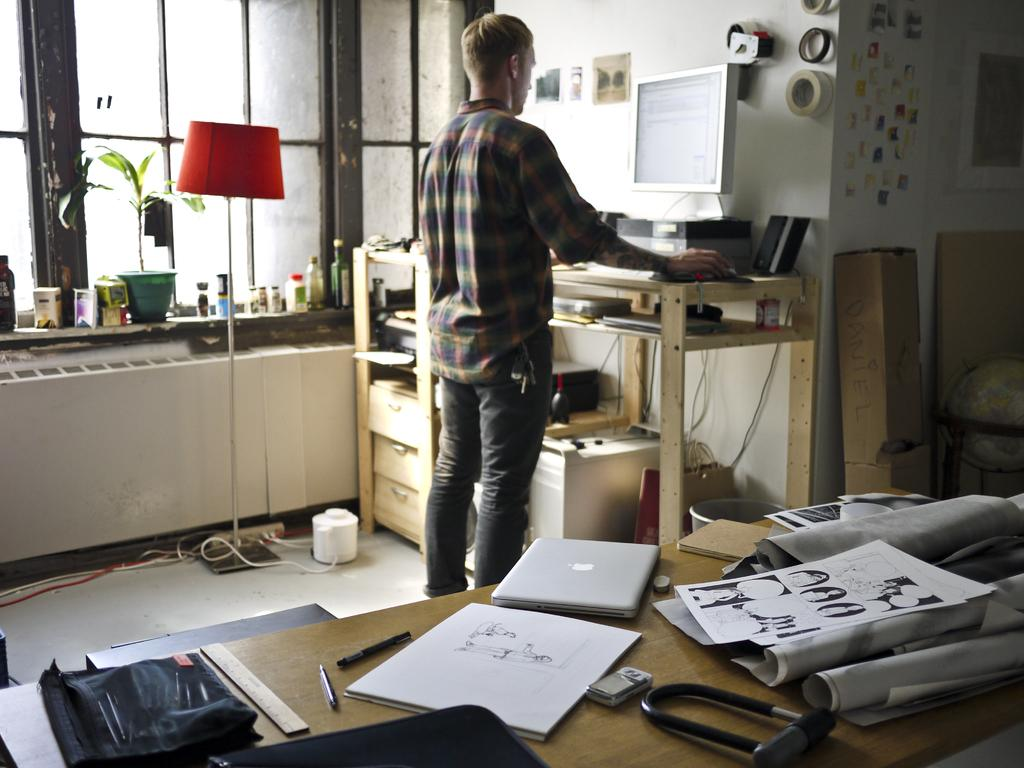What is the man in the image doing? The man is operating a computer. What can be seen behind the man? There is a lamp behind the man. What is on the window in the image? There is a pot on the window. What other electronic device is present in the image? There is a laptop on another table. What is on the table with the laptop? There are papers on the table with the laptop. How many horses are visible in the image? There are no horses present in the image. What color is the head of the man in the image? The provided facts do not mention the color of the man's head, and it cannot be determined from the image alone. 